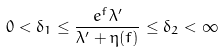Convert formula to latex. <formula><loc_0><loc_0><loc_500><loc_500>0 < \delta _ { 1 } \leq \frac { e ^ { f } \lambda ^ { \prime } } { \lambda ^ { \prime } + \eta ( f ) } \leq \delta _ { 2 } < \infty</formula> 